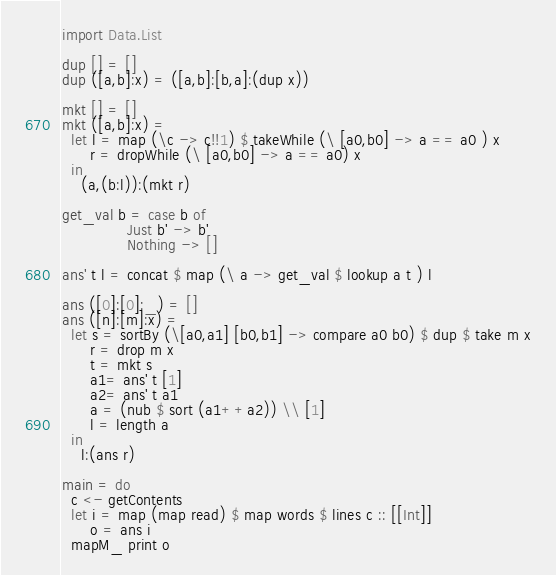<code> <loc_0><loc_0><loc_500><loc_500><_Haskell_>import Data.List

dup [] = []
dup ([a,b]:x) = ([a,b]:[b,a]:(dup x))

mkt [] = []
mkt ([a,b]:x) =
  let l = map (\c -> c!!1) $ takeWhile (\ [a0,b0] -> a == a0 ) x
      r = dropWhile (\ [a0,b0] -> a == a0) x
  in
    (a,(b:l)):(mkt r)

get_val b = case b of
              Just b' -> b'
              Nothing -> []

ans' t l = concat $ map (\ a -> get_val $ lookup a t ) l

ans ([0]:[0]:_) = []
ans ([n]:[m]:x) =
  let s = sortBy (\[a0,a1] [b0,b1] -> compare a0 b0) $ dup $ take m x
      r = drop m x
      t = mkt s
      a1= ans' t [1]
      a2= ans' t a1
      a = (nub $ sort (a1++a2)) \\ [1]
      l = length a
  in
    l:(ans r)

main = do
  c <- getContents
  let i = map (map read) $ map words $ lines c :: [[Int]]
      o = ans i
  mapM_ print o


</code> 